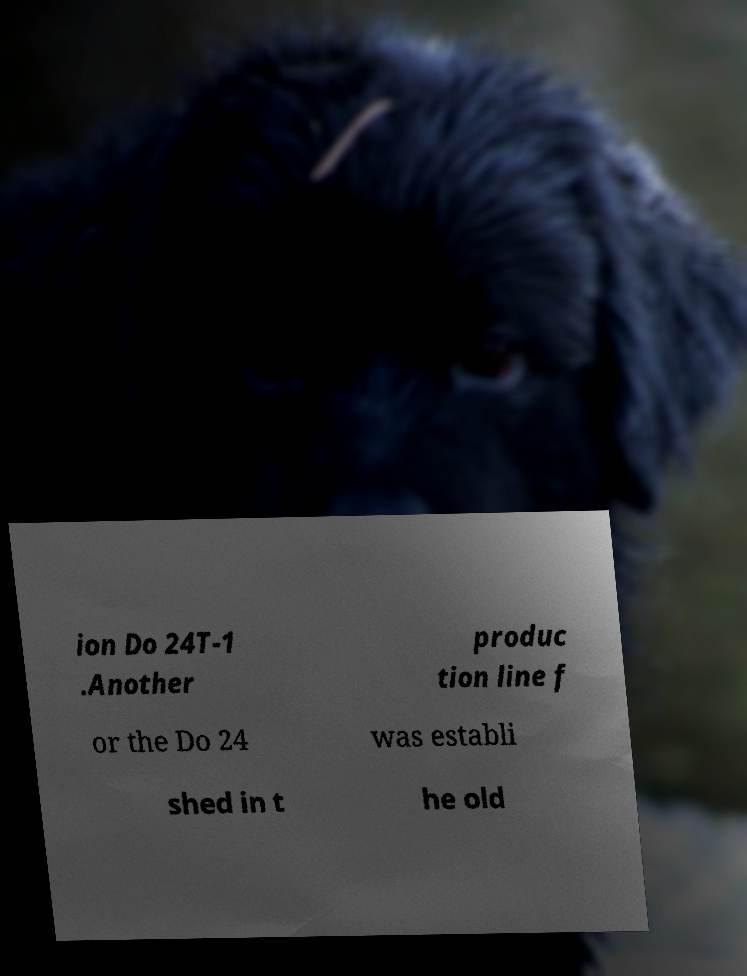Could you assist in decoding the text presented in this image and type it out clearly? ion Do 24T-1 .Another produc tion line f or the Do 24 was establi shed in t he old 